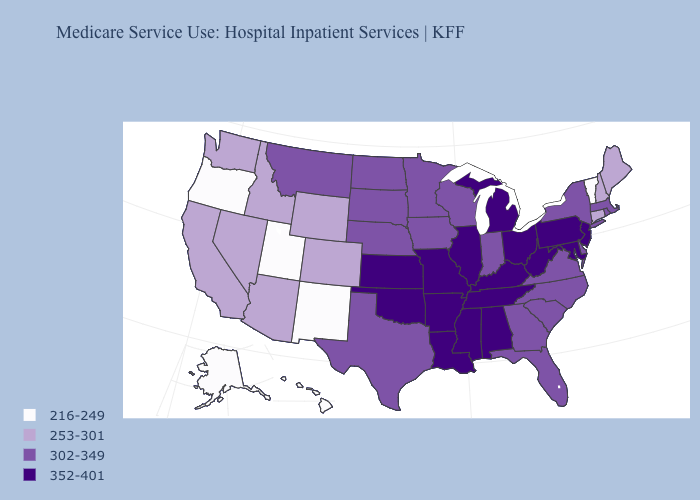What is the value of West Virginia?
Quick response, please. 352-401. What is the highest value in the USA?
Short answer required. 352-401. Name the states that have a value in the range 352-401?
Be succinct. Alabama, Arkansas, Illinois, Kansas, Kentucky, Louisiana, Maryland, Michigan, Mississippi, Missouri, New Jersey, Ohio, Oklahoma, Pennsylvania, Tennessee, West Virginia. Name the states that have a value in the range 253-301?
Keep it brief. Arizona, California, Colorado, Connecticut, Idaho, Maine, Nevada, New Hampshire, Washington, Wyoming. What is the value of Pennsylvania?
Concise answer only. 352-401. Which states hav the highest value in the Northeast?
Write a very short answer. New Jersey, Pennsylvania. What is the highest value in the West ?
Short answer required. 302-349. Among the states that border Ohio , does Michigan have the highest value?
Keep it brief. Yes. Name the states that have a value in the range 352-401?
Concise answer only. Alabama, Arkansas, Illinois, Kansas, Kentucky, Louisiana, Maryland, Michigan, Mississippi, Missouri, New Jersey, Ohio, Oklahoma, Pennsylvania, Tennessee, West Virginia. What is the highest value in states that border Louisiana?
Answer briefly. 352-401. Does Rhode Island have a higher value than Michigan?
Write a very short answer. No. What is the lowest value in states that border North Dakota?
Concise answer only. 302-349. What is the value of Minnesota?
Concise answer only. 302-349. What is the value of Florida?
Short answer required. 302-349. What is the value of Kentucky?
Write a very short answer. 352-401. 